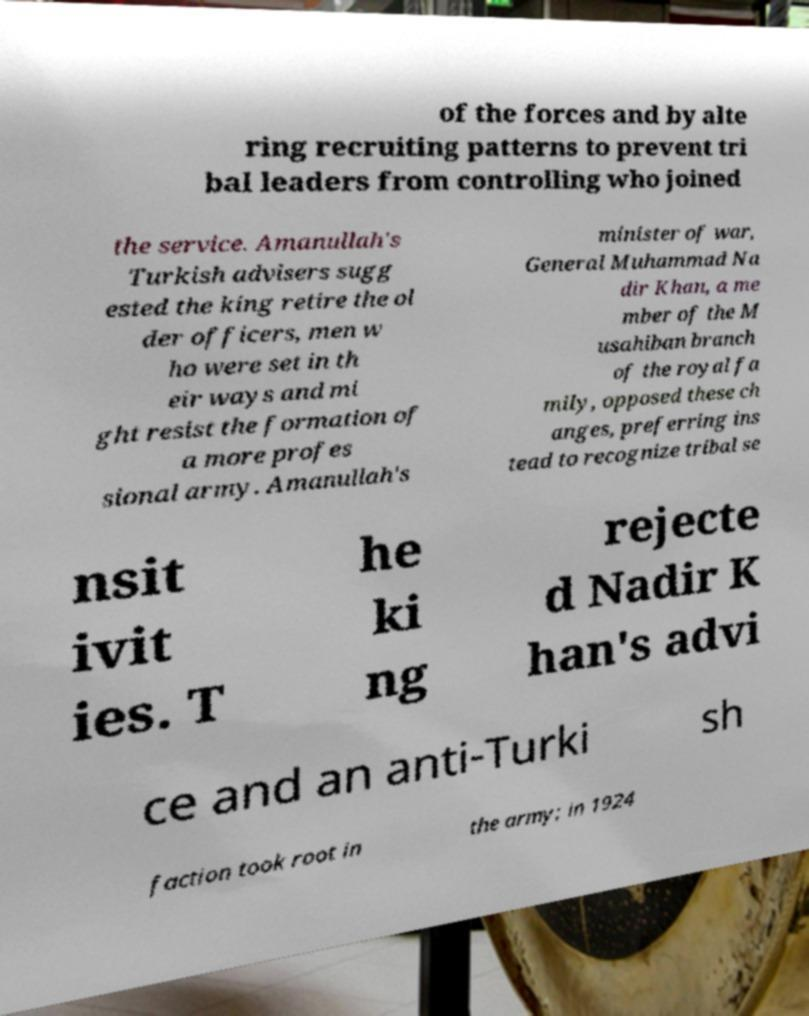Can you accurately transcribe the text from the provided image for me? of the forces and by alte ring recruiting patterns to prevent tri bal leaders from controlling who joined the service. Amanullah's Turkish advisers sugg ested the king retire the ol der officers, men w ho were set in th eir ways and mi ght resist the formation of a more profes sional army. Amanullah's minister of war, General Muhammad Na dir Khan, a me mber of the M usahiban branch of the royal fa mily, opposed these ch anges, preferring ins tead to recognize tribal se nsit ivit ies. T he ki ng rejecte d Nadir K han's advi ce and an anti-Turki sh faction took root in the army; in 1924 